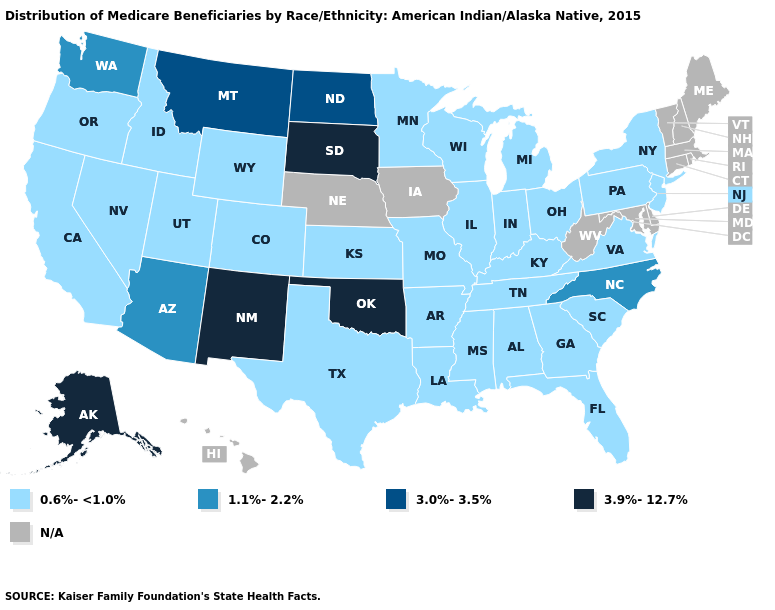What is the value of Maine?
Quick response, please. N/A. What is the value of Arkansas?
Concise answer only. 0.6%-<1.0%. Which states have the lowest value in the South?
Concise answer only. Alabama, Arkansas, Florida, Georgia, Kentucky, Louisiana, Mississippi, South Carolina, Tennessee, Texas, Virginia. Which states have the highest value in the USA?
Quick response, please. Alaska, New Mexico, Oklahoma, South Dakota. Name the states that have a value in the range 1.1%-2.2%?
Write a very short answer. Arizona, North Carolina, Washington. Which states have the lowest value in the USA?
Short answer required. Alabama, Arkansas, California, Colorado, Florida, Georgia, Idaho, Illinois, Indiana, Kansas, Kentucky, Louisiana, Michigan, Minnesota, Mississippi, Missouri, Nevada, New Jersey, New York, Ohio, Oregon, Pennsylvania, South Carolina, Tennessee, Texas, Utah, Virginia, Wisconsin, Wyoming. Name the states that have a value in the range 0.6%-<1.0%?
Answer briefly. Alabama, Arkansas, California, Colorado, Florida, Georgia, Idaho, Illinois, Indiana, Kansas, Kentucky, Louisiana, Michigan, Minnesota, Mississippi, Missouri, Nevada, New Jersey, New York, Ohio, Oregon, Pennsylvania, South Carolina, Tennessee, Texas, Utah, Virginia, Wisconsin, Wyoming. Name the states that have a value in the range 0.6%-<1.0%?
Concise answer only. Alabama, Arkansas, California, Colorado, Florida, Georgia, Idaho, Illinois, Indiana, Kansas, Kentucky, Louisiana, Michigan, Minnesota, Mississippi, Missouri, Nevada, New Jersey, New York, Ohio, Oregon, Pennsylvania, South Carolina, Tennessee, Texas, Utah, Virginia, Wisconsin, Wyoming. How many symbols are there in the legend?
Quick response, please. 5. Among the states that border Nebraska , which have the highest value?
Write a very short answer. South Dakota. Among the states that border Washington , which have the highest value?
Write a very short answer. Idaho, Oregon. Which states have the lowest value in the USA?
Concise answer only. Alabama, Arkansas, California, Colorado, Florida, Georgia, Idaho, Illinois, Indiana, Kansas, Kentucky, Louisiana, Michigan, Minnesota, Mississippi, Missouri, Nevada, New Jersey, New York, Ohio, Oregon, Pennsylvania, South Carolina, Tennessee, Texas, Utah, Virginia, Wisconsin, Wyoming. Is the legend a continuous bar?
Concise answer only. No. Is the legend a continuous bar?
Quick response, please. No. 